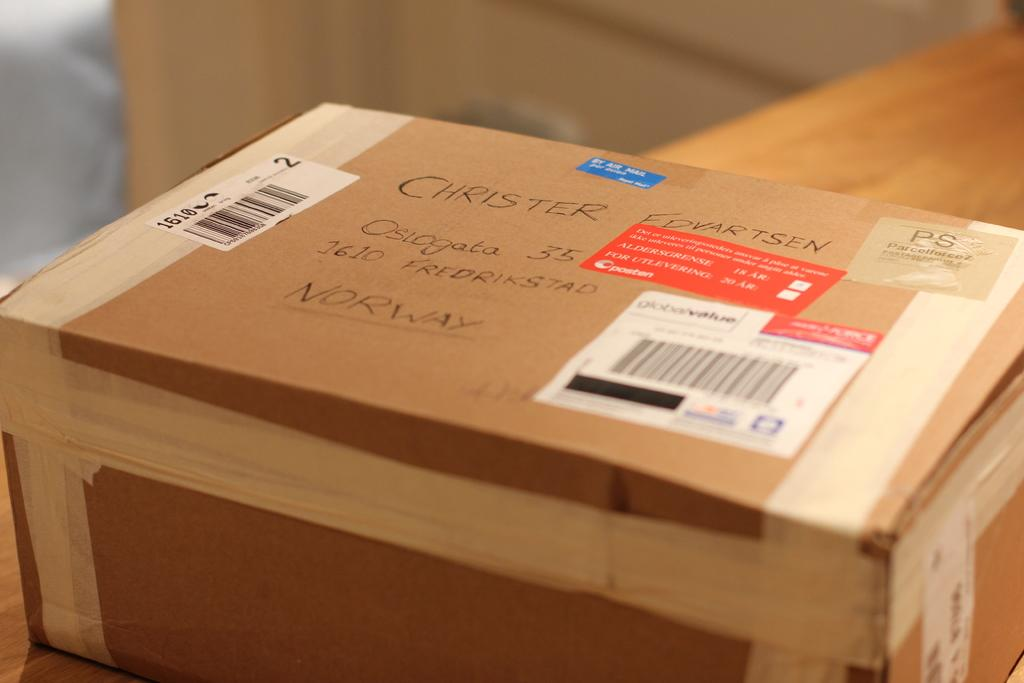<image>
Describe the image concisely. a package ready for deliver going to Norway 